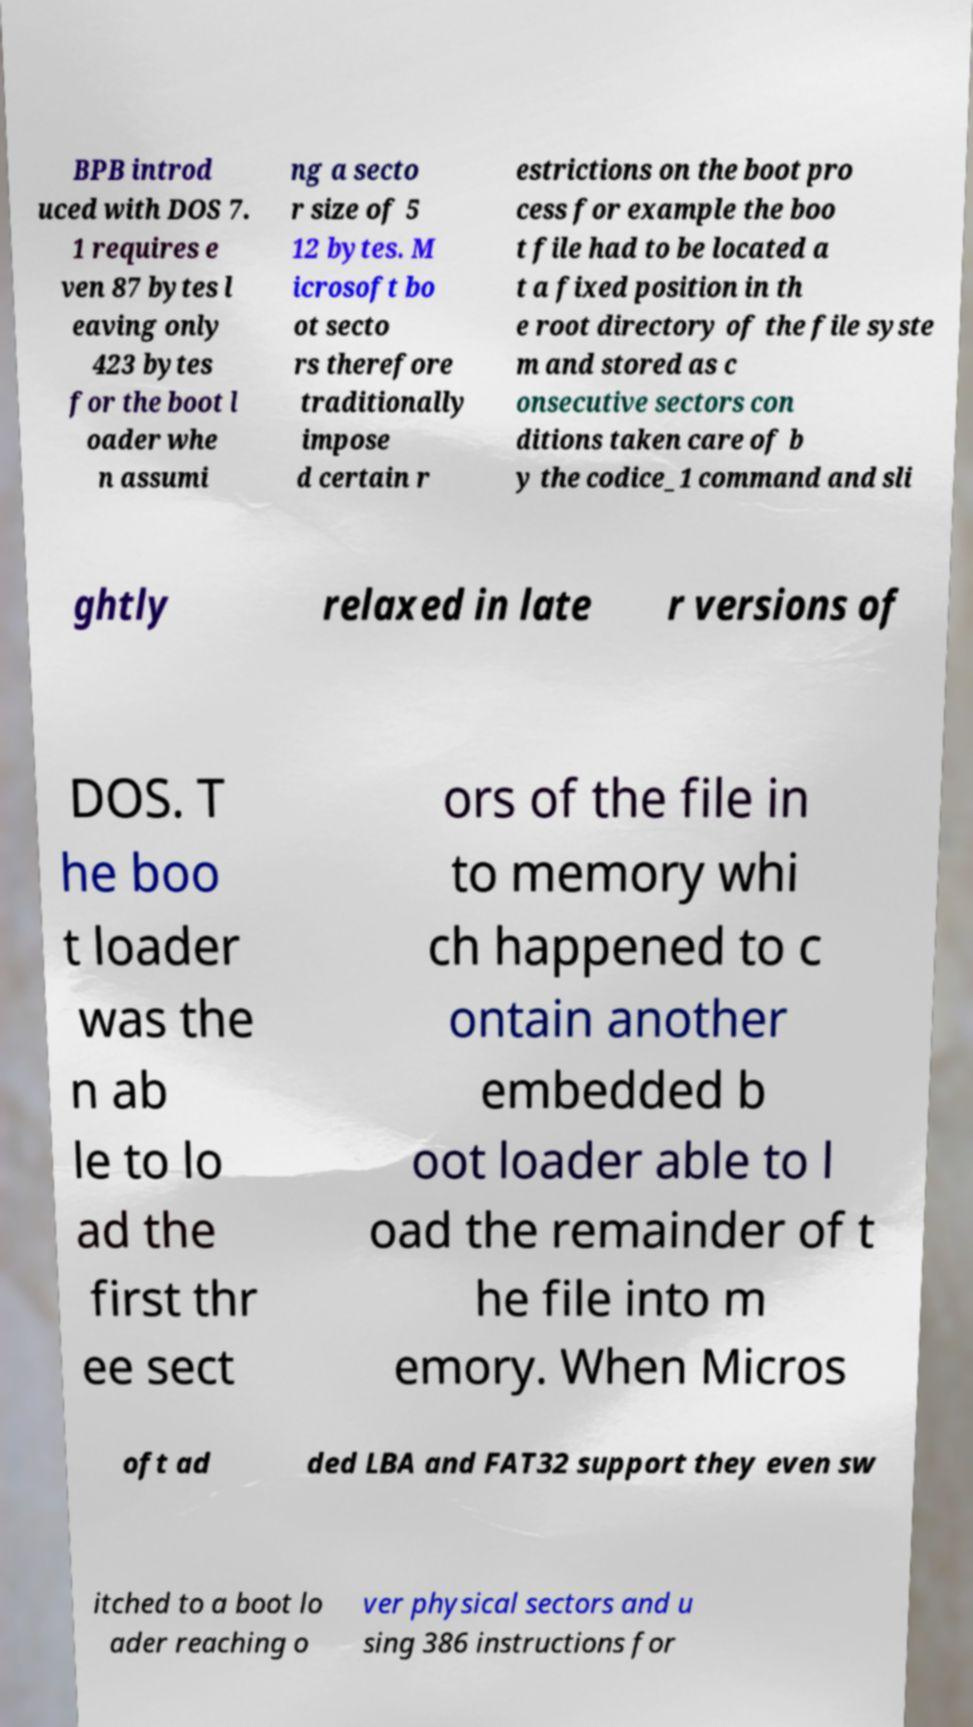Could you assist in decoding the text presented in this image and type it out clearly? BPB introd uced with DOS 7. 1 requires e ven 87 bytes l eaving only 423 bytes for the boot l oader whe n assumi ng a secto r size of 5 12 bytes. M icrosoft bo ot secto rs therefore traditionally impose d certain r estrictions on the boot pro cess for example the boo t file had to be located a t a fixed position in th e root directory of the file syste m and stored as c onsecutive sectors con ditions taken care of b y the codice_1 command and sli ghtly relaxed in late r versions of DOS. T he boo t loader was the n ab le to lo ad the first thr ee sect ors of the file in to memory whi ch happened to c ontain another embedded b oot loader able to l oad the remainder of t he file into m emory. When Micros oft ad ded LBA and FAT32 support they even sw itched to a boot lo ader reaching o ver physical sectors and u sing 386 instructions for 